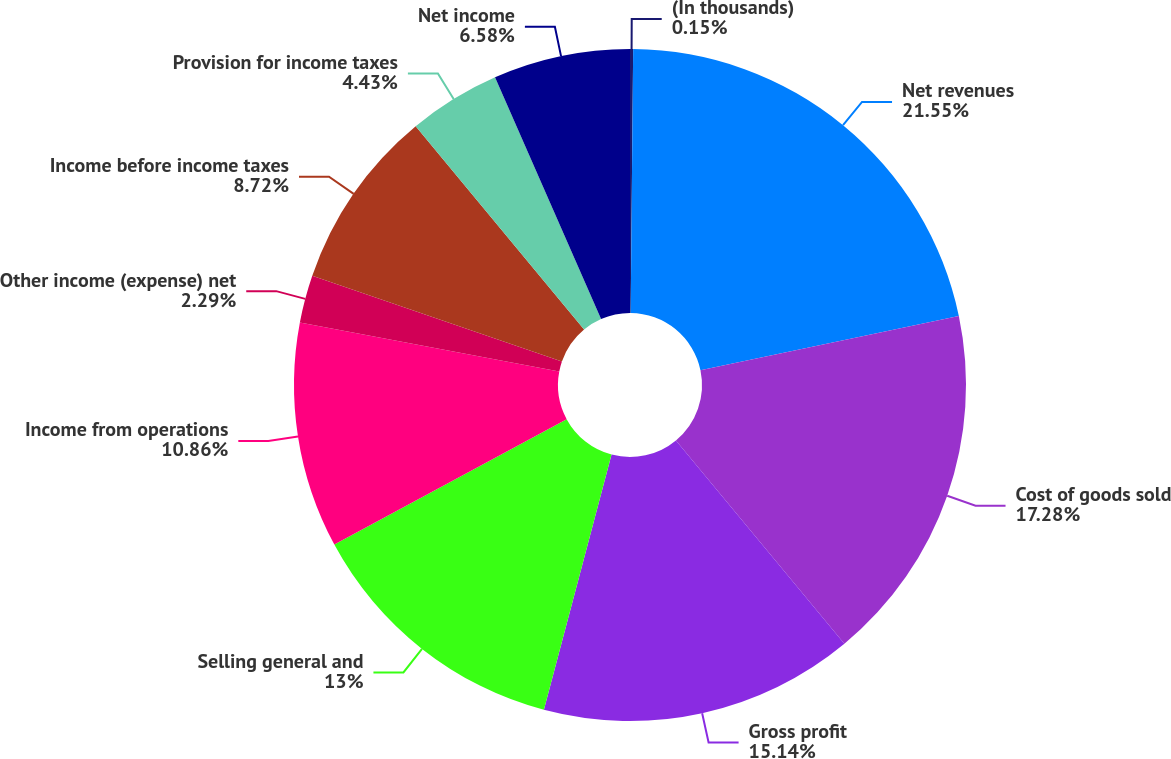<chart> <loc_0><loc_0><loc_500><loc_500><pie_chart><fcel>(In thousands)<fcel>Net revenues<fcel>Cost of goods sold<fcel>Gross profit<fcel>Selling general and<fcel>Income from operations<fcel>Other income (expense) net<fcel>Income before income taxes<fcel>Provision for income taxes<fcel>Net income<nl><fcel>0.15%<fcel>21.56%<fcel>17.28%<fcel>15.14%<fcel>13.0%<fcel>10.86%<fcel>2.29%<fcel>8.72%<fcel>4.43%<fcel>6.58%<nl></chart> 